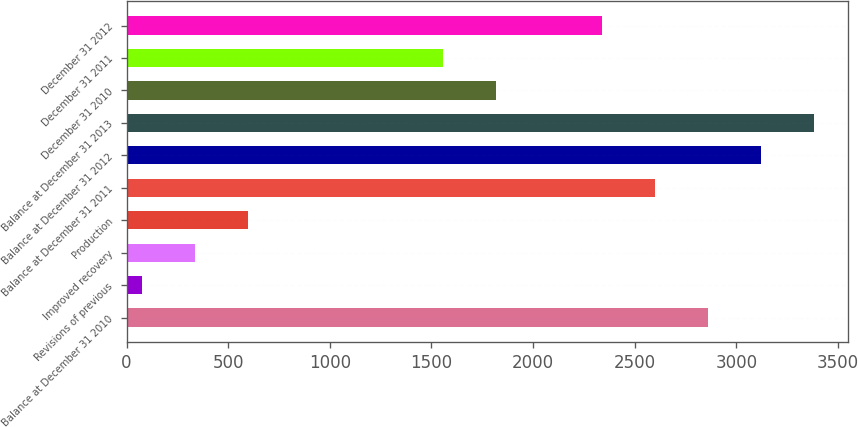<chart> <loc_0><loc_0><loc_500><loc_500><bar_chart><fcel>Balance at December 31 2010<fcel>Revisions of previous<fcel>Improved recovery<fcel>Production<fcel>Balance at December 31 2011<fcel>Balance at December 31 2012<fcel>Balance at December 31 2013<fcel>December 31 2010<fcel>December 31 2011<fcel>December 31 2012<nl><fcel>2859.5<fcel>78<fcel>338.9<fcel>599.8<fcel>2598.6<fcel>3120.4<fcel>3381.3<fcel>1815.9<fcel>1555<fcel>2337.7<nl></chart> 